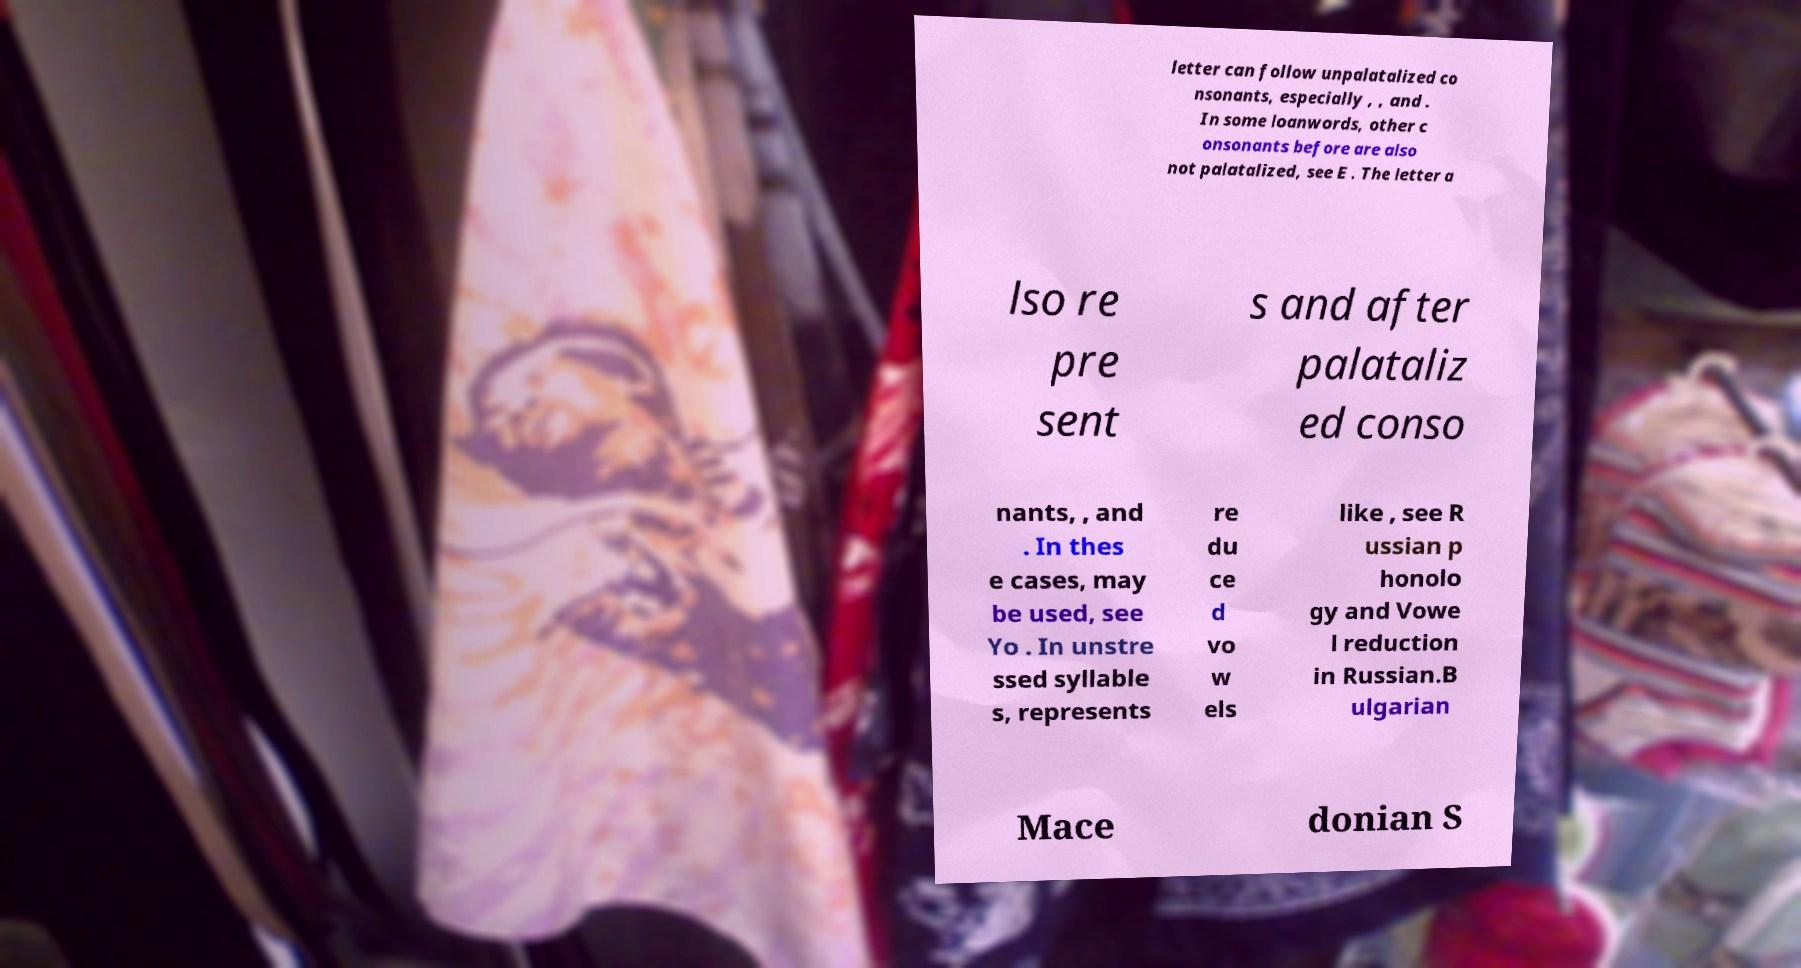What messages or text are displayed in this image? I need them in a readable, typed format. letter can follow unpalatalized co nsonants, especially , , and . In some loanwords, other c onsonants before are also not palatalized, see E . The letter a lso re pre sent s and after palataliz ed conso nants, , and . In thes e cases, may be used, see Yo . In unstre ssed syllable s, represents re du ce d vo w els like , see R ussian p honolo gy and Vowe l reduction in Russian.B ulgarian Mace donian S 